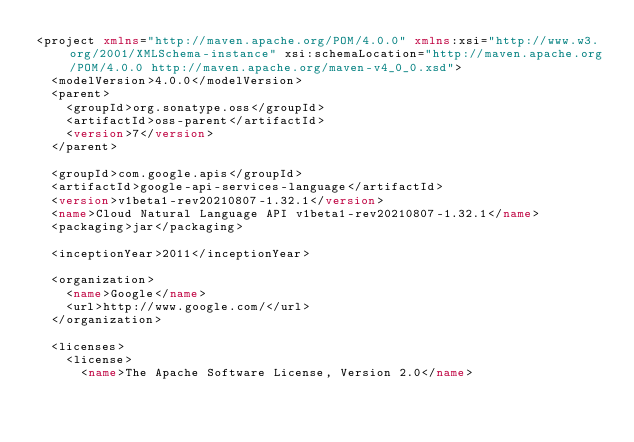<code> <loc_0><loc_0><loc_500><loc_500><_XML_><project xmlns="http://maven.apache.org/POM/4.0.0" xmlns:xsi="http://www.w3.org/2001/XMLSchema-instance" xsi:schemaLocation="http://maven.apache.org/POM/4.0.0 http://maven.apache.org/maven-v4_0_0.xsd">
  <modelVersion>4.0.0</modelVersion>
  <parent>
    <groupId>org.sonatype.oss</groupId>
    <artifactId>oss-parent</artifactId>
    <version>7</version>
  </parent>

  <groupId>com.google.apis</groupId>
  <artifactId>google-api-services-language</artifactId>
  <version>v1beta1-rev20210807-1.32.1</version>
  <name>Cloud Natural Language API v1beta1-rev20210807-1.32.1</name>
  <packaging>jar</packaging>

  <inceptionYear>2011</inceptionYear>

  <organization>
    <name>Google</name>
    <url>http://www.google.com/</url>
  </organization>

  <licenses>
    <license>
      <name>The Apache Software License, Version 2.0</name></code> 